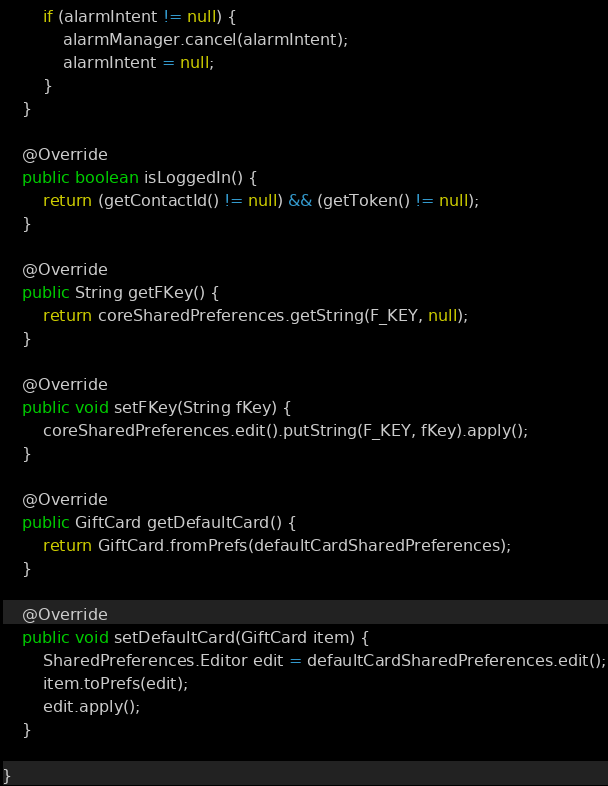Convert code to text. <code><loc_0><loc_0><loc_500><loc_500><_Java_>        if (alarmIntent != null) {
            alarmManager.cancel(alarmIntent);
            alarmIntent = null;
        }
    }

    @Override
    public boolean isLoggedIn() {
        return (getContactId() != null) && (getToken() != null);
    }

    @Override
    public String getFKey() {
        return coreSharedPreferences.getString(F_KEY, null);
    }

    @Override
    public void setFKey(String fKey) {
        coreSharedPreferences.edit().putString(F_KEY, fKey).apply();
    }

    @Override
    public GiftCard getDefaultCard() {
        return GiftCard.fromPrefs(defaultCardSharedPreferences);
    }

    @Override
    public void setDefaultCard(GiftCard item) {
        SharedPreferences.Editor edit = defaultCardSharedPreferences.edit();
        item.toPrefs(edit);
        edit.apply();
    }

}</code> 